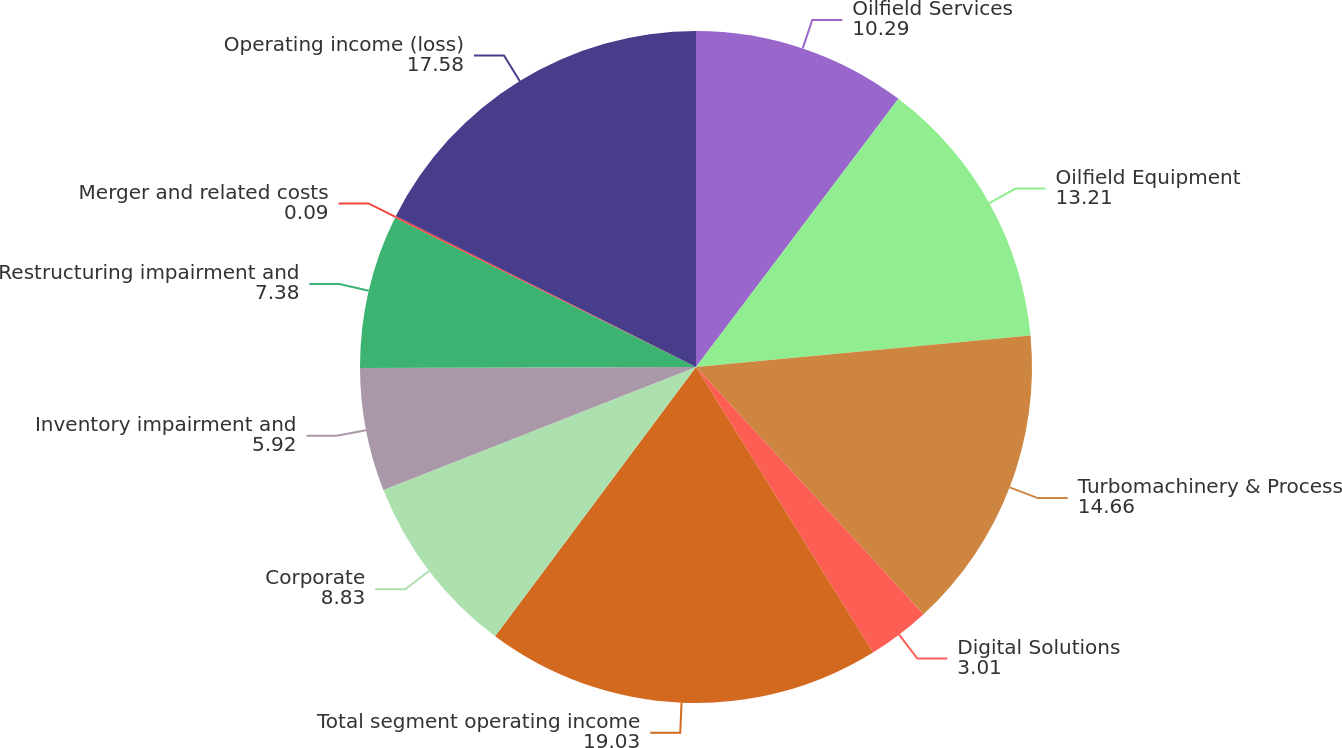Convert chart to OTSL. <chart><loc_0><loc_0><loc_500><loc_500><pie_chart><fcel>Oilfield Services<fcel>Oilfield Equipment<fcel>Turbomachinery & Process<fcel>Digital Solutions<fcel>Total segment operating income<fcel>Corporate<fcel>Inventory impairment and<fcel>Restructuring impairment and<fcel>Merger and related costs<fcel>Operating income (loss)<nl><fcel>10.29%<fcel>13.21%<fcel>14.66%<fcel>3.01%<fcel>19.03%<fcel>8.83%<fcel>5.92%<fcel>7.38%<fcel>0.09%<fcel>17.58%<nl></chart> 